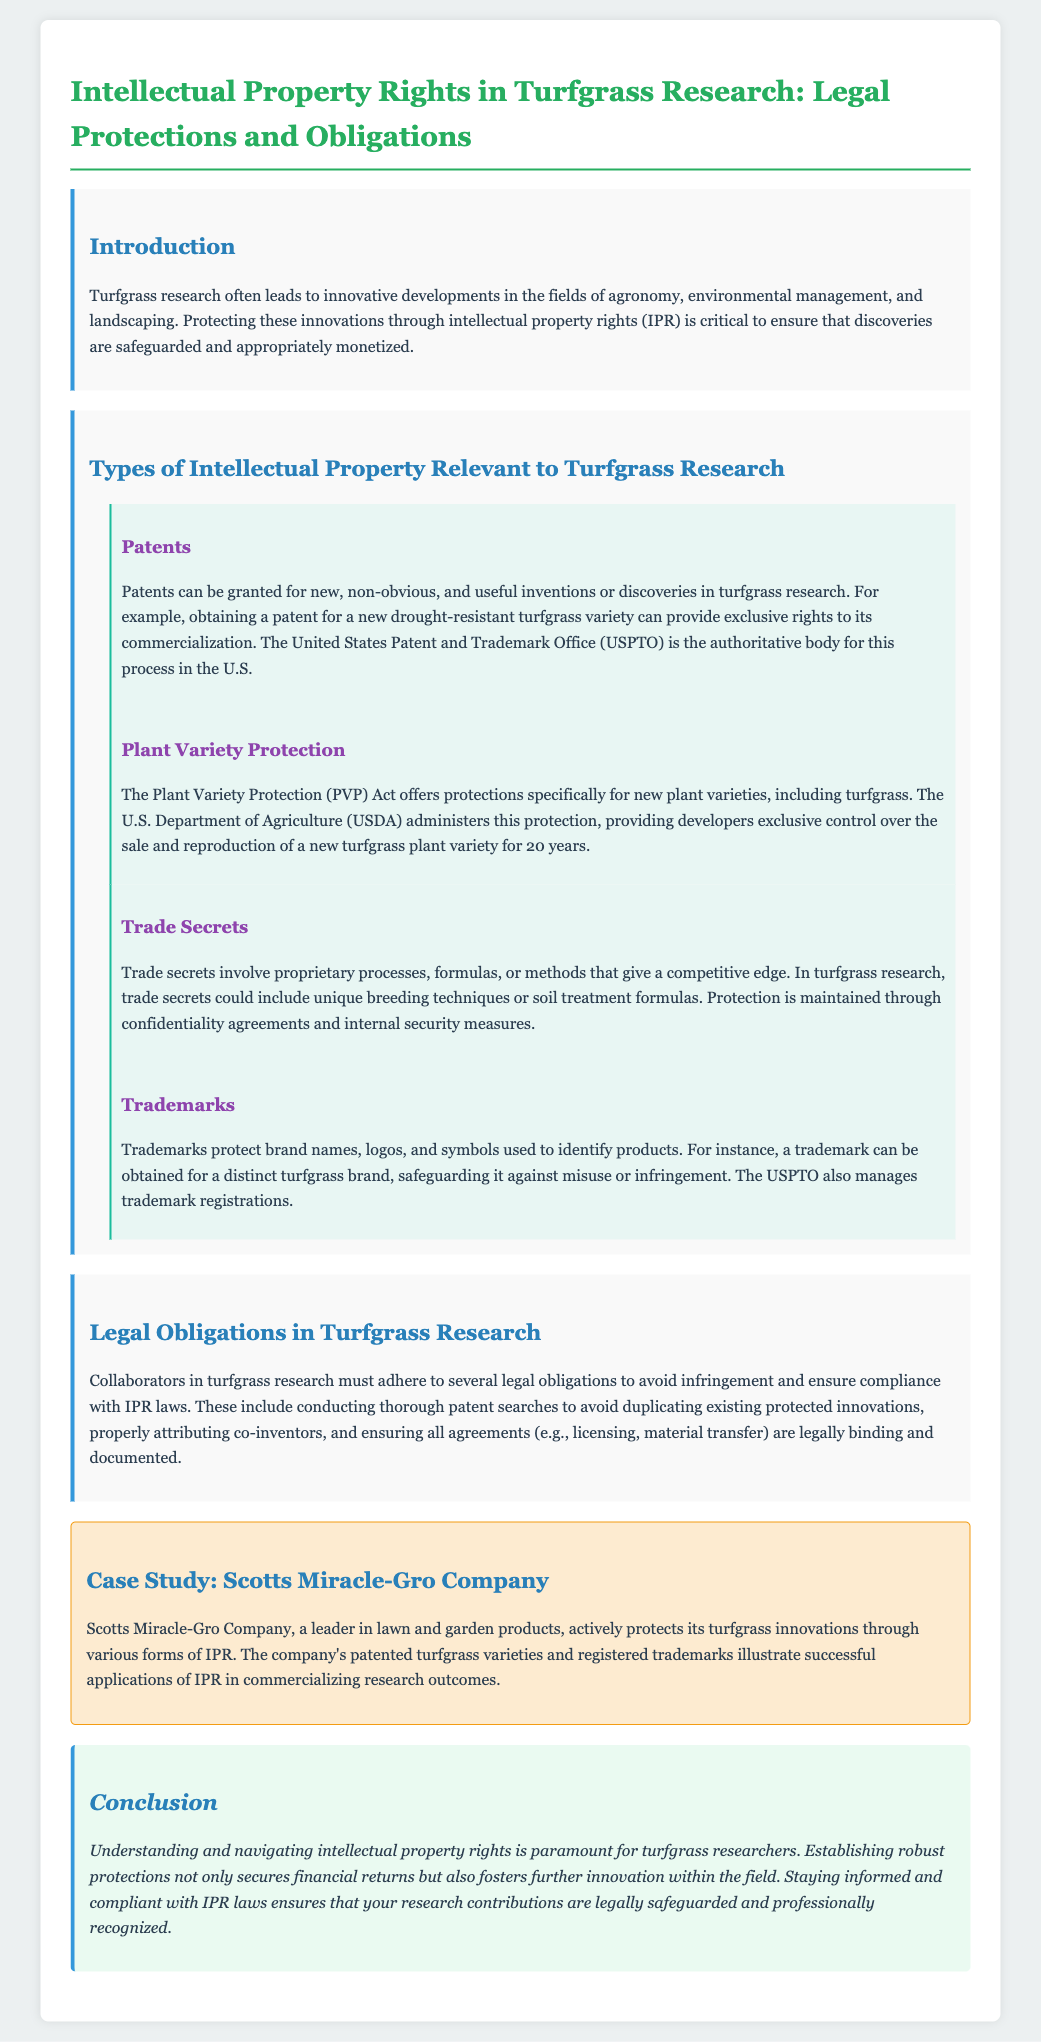What is the purpose of the legal brief? The purpose of the legal brief is to discuss the importance of protecting innovations in turfgrass research through intellectual property rights.
Answer: To discuss the importance of protecting innovations What federal body administers the Plant Variety Protection Act? The document states that the U.S. Department of Agriculture administers the Plant Variety Protection Act.
Answer: U.S. Department of Agriculture How long is the protection period for new plant varieties under the PVP Act? The legal brief specifies that the protection period is for 20 years.
Answer: 20 years What kind of protection does a trademark provide? The brief mentions that trademarks protect brand names, logos, and symbols used to identify products.
Answer: Brand names, logos, and symbols What must collaborators in turfgrass research conduct to avoid infringement? It is stated that collaborators must conduct thorough patent searches to avoid duplicating existing protected innovations.
Answer: Thorough patent searches Why is understanding intellectual property rights important for turfgrass researchers? The importance is highlighted as it secures financial returns and fosters further innovation within the field.
Answer: Secures financial returns and fosters innovation Which company is used as a case study in the document? The document mentions Scotts Miracle-Gro Company as the case study for its IPR practices.
Answer: Scotts Miracle-Gro Company What form of IPR does Scotts Miracle-Gro Company actively protect? The brief indicates that the company protects its turfgrass innovations through various forms of intellectual property rights.
Answer: Various forms of intellectual property rights 